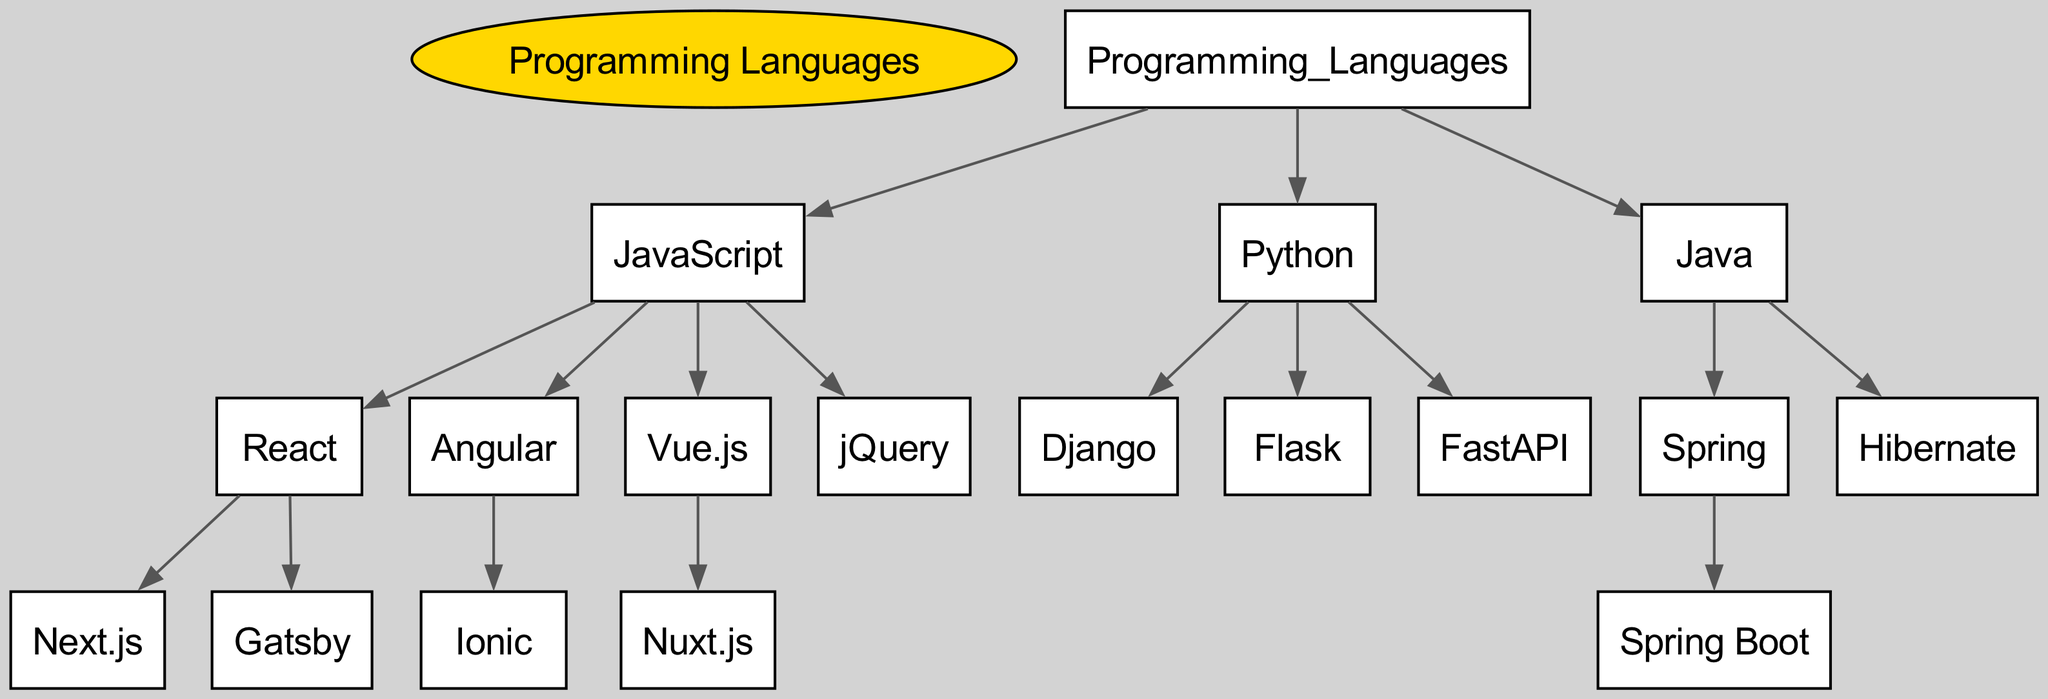What is the root of this family tree? The root node represents the main category from which all other nodes branch out. According to the diagram, the root is labeled as "Programming Languages," which signifies the overarching theme of the family tree.
Answer: Programming Languages How many children does JavaScript have? To find the number of JavaScript's children, we can look under the JavaScript node and count the names listed as its direct descendants. JavaScript has four children: React, Angular, Vue.js, and jQuery.
Answer: 4 Which framework is a child of Django? The diagram shows that Django has no children listed under it, meaning it does not have any frameworks that depend on it in this lineage chart. Therefore, there is no child framework for Django.
Answer: None What programming language is the parent of Hibernate? To determine the parent of Hibernate, we locate it in the diagram and check which node is directly connected to it. Hibernate is placed under the Java node, indicating that Java is its parent programming language.
Answer: Java Which framework has the most immediate children? By examining the immediate children of each framework in the diagram, we can analyze which one has the most direct descendants. React is seen to have two immediate children: Next.js and Gatsby, making it the framework with the most children in this lineage chart.
Answer: React How many total frameworks are listed under Python? We look specifically at the Python node and count all the frameworks that are children of it. The frameworks listed under Python are Django, Flask, and FastAPI, resulting in a total of three frameworks.
Answer: 3 What color is used to represent JavaScript in this diagram? Each programming language in the diagram is represented by a specific color according to its defined attributes. For JavaScript, the color used is light blue, which can be associated with the configured properties in the graph.
Answer: Light blue Which framework from Java has a child framework? In the Java section of the diagram, Spring is identified as the only framework that has a child framework, namely Spring Boot. This can be concluded by exploring the hierarchy of frameworks listed under the Java parent.
Answer: Spring 